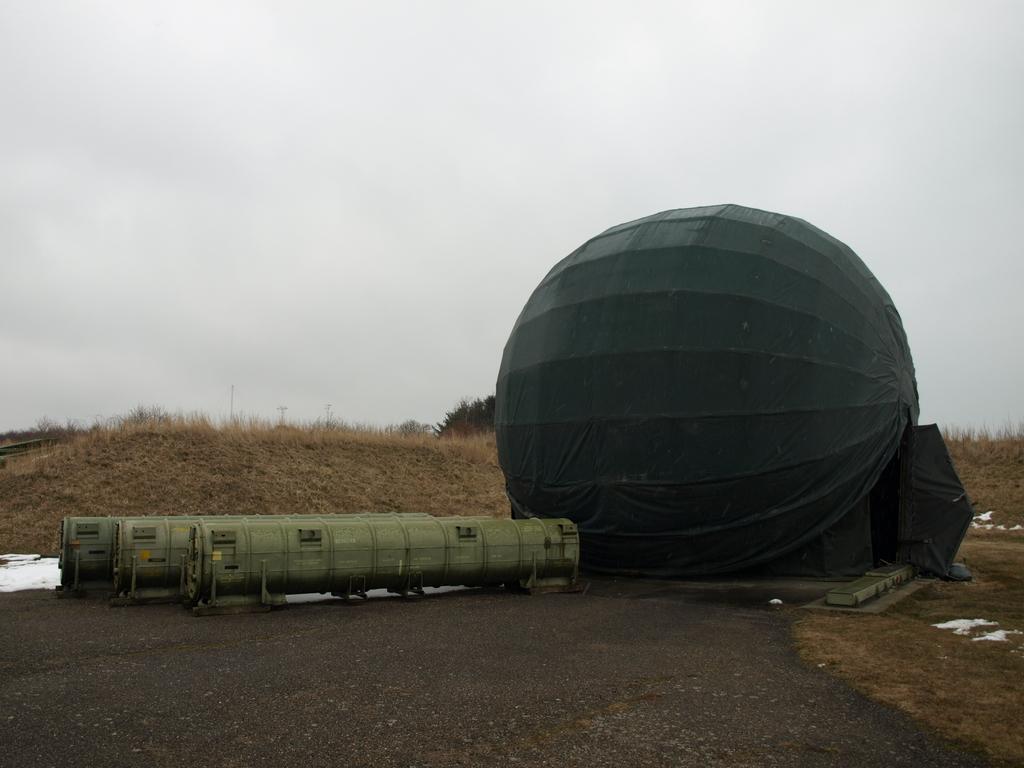Please provide a concise description of this image. In this picture we can see metal objects and a spherical object with a black cloth on it, grass, trees and in the background we can see the sky. 